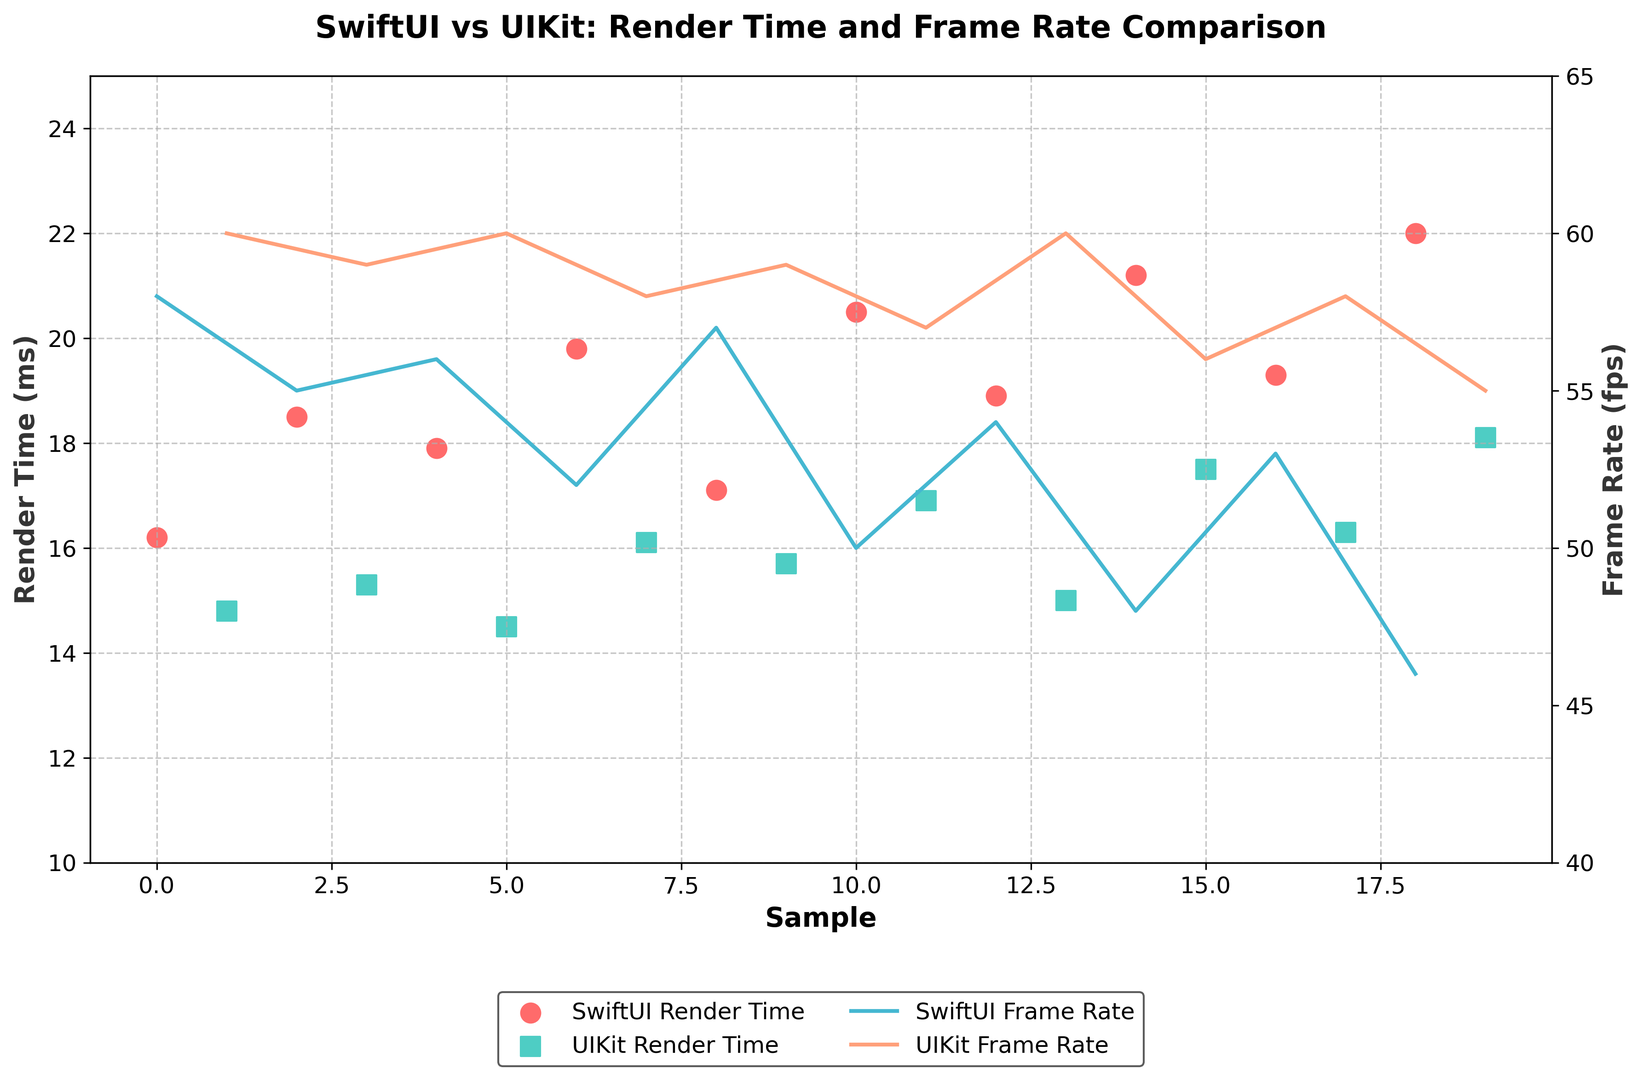What's the average render time for SwiftUI? To find the average render time for SwiftUI, sum up all the render times for SwiftUI and divide by the number of data points. The render times are 16.2, 18.5, 17.9, 19.8, 17.1, 20.5, 18.9, 21.2, 19.3, 22.0. Sum is 191.4. There are 10 data points, so 191.4 / 10 = 19.14
Answer: 19.14 What's the average frame rate for UIKit? To calculate the average frame rate for UIKit, sum up all the frame rates for UIKit and divide by the number of data points. The frame rates are 60, 59, 60, 58, 59, 60, 57, 60, 58, 59, 60, 55, 58. Sum is 623. There are 13 data points, so 623 / 13 ≈ 57.61
Answer: 57.61 Which UI framework has the lowest render time? Compare the minimum render times for both SwiftUI and UIKit. SwiftUI's minimum render time is 16.2 ms, and UIKit's minimum render time is 14.5 ms.
Answer: UIKit Which UI framework achieves the highest frame rate, and what is it? Compare the maximum frame rates for both SwiftUI and UIKit. SwiftUI's maximum frame rate is 58 fps, and UIKit's maximum frame rate is 60 fps.
Answer: UIKit, 60 fps How does the highest render time for SwiftUI compare to the highest render time for UIKit? Identify the highest render times for SwiftUI and UIKit. SwiftUI's highest render time is 22.0 ms, and UIKit's highest render time is 16.9 ms. 22.0 ms is higher than 16.9 ms.
Answer: SwiftUI's highest render time is 5.1 ms greater than UIKit's Is there a sample where UIKit and SwiftUI have the same frame rate? Look at the frame rate data points for both SwiftUI and UIKit. One instance where they share the same frame rate is when both have 58 fps.
Answer: Yes Which color represents the render time for UIKit in the figure? In the visual attributes description of the figure, it mentions that the render time for UIKit is represented by scatter plots colored green with square markers.
Answer: green What's the difference between the lowest and highest frame rate for SwiftUI? Find SwiftUI's frame rates and identify the lowest (46 fps) and highest (58 fps). The difference is 58 - 46 = 12 fps.
Answer: 12 fps How does the average render time for SwiftUI compare to the average render time for UIKit? Calculate and compare the average render times for both. SwiftUI's average render time is 19.14 ms, and UIKit's average render time is (14.8 + 15.3 + 14.5 + 16.1 + 15.7 + 16.9 + 15.0 + 17.5 + 16.3 + 18.1) / 10 = 16.02 ms. The difference is 19.14 - 16.02 = 3.12 ms.
Answer: SwiftUI's average render time is 3.12 ms higher than UIKit's 